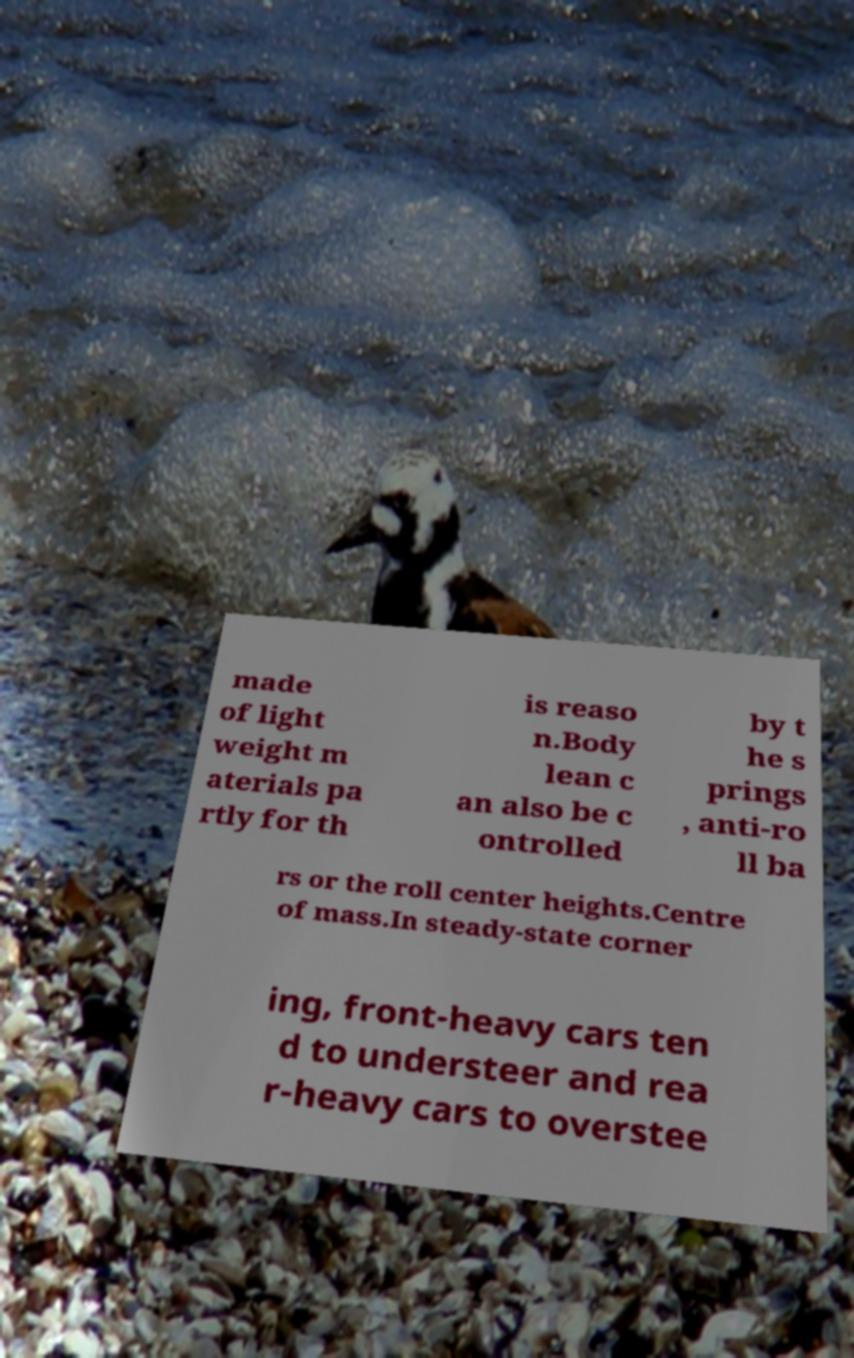I need the written content from this picture converted into text. Can you do that? made of light weight m aterials pa rtly for th is reaso n.Body lean c an also be c ontrolled by t he s prings , anti-ro ll ba rs or the roll center heights.Centre of mass.In steady-state corner ing, front-heavy cars ten d to understeer and rea r-heavy cars to overstee 